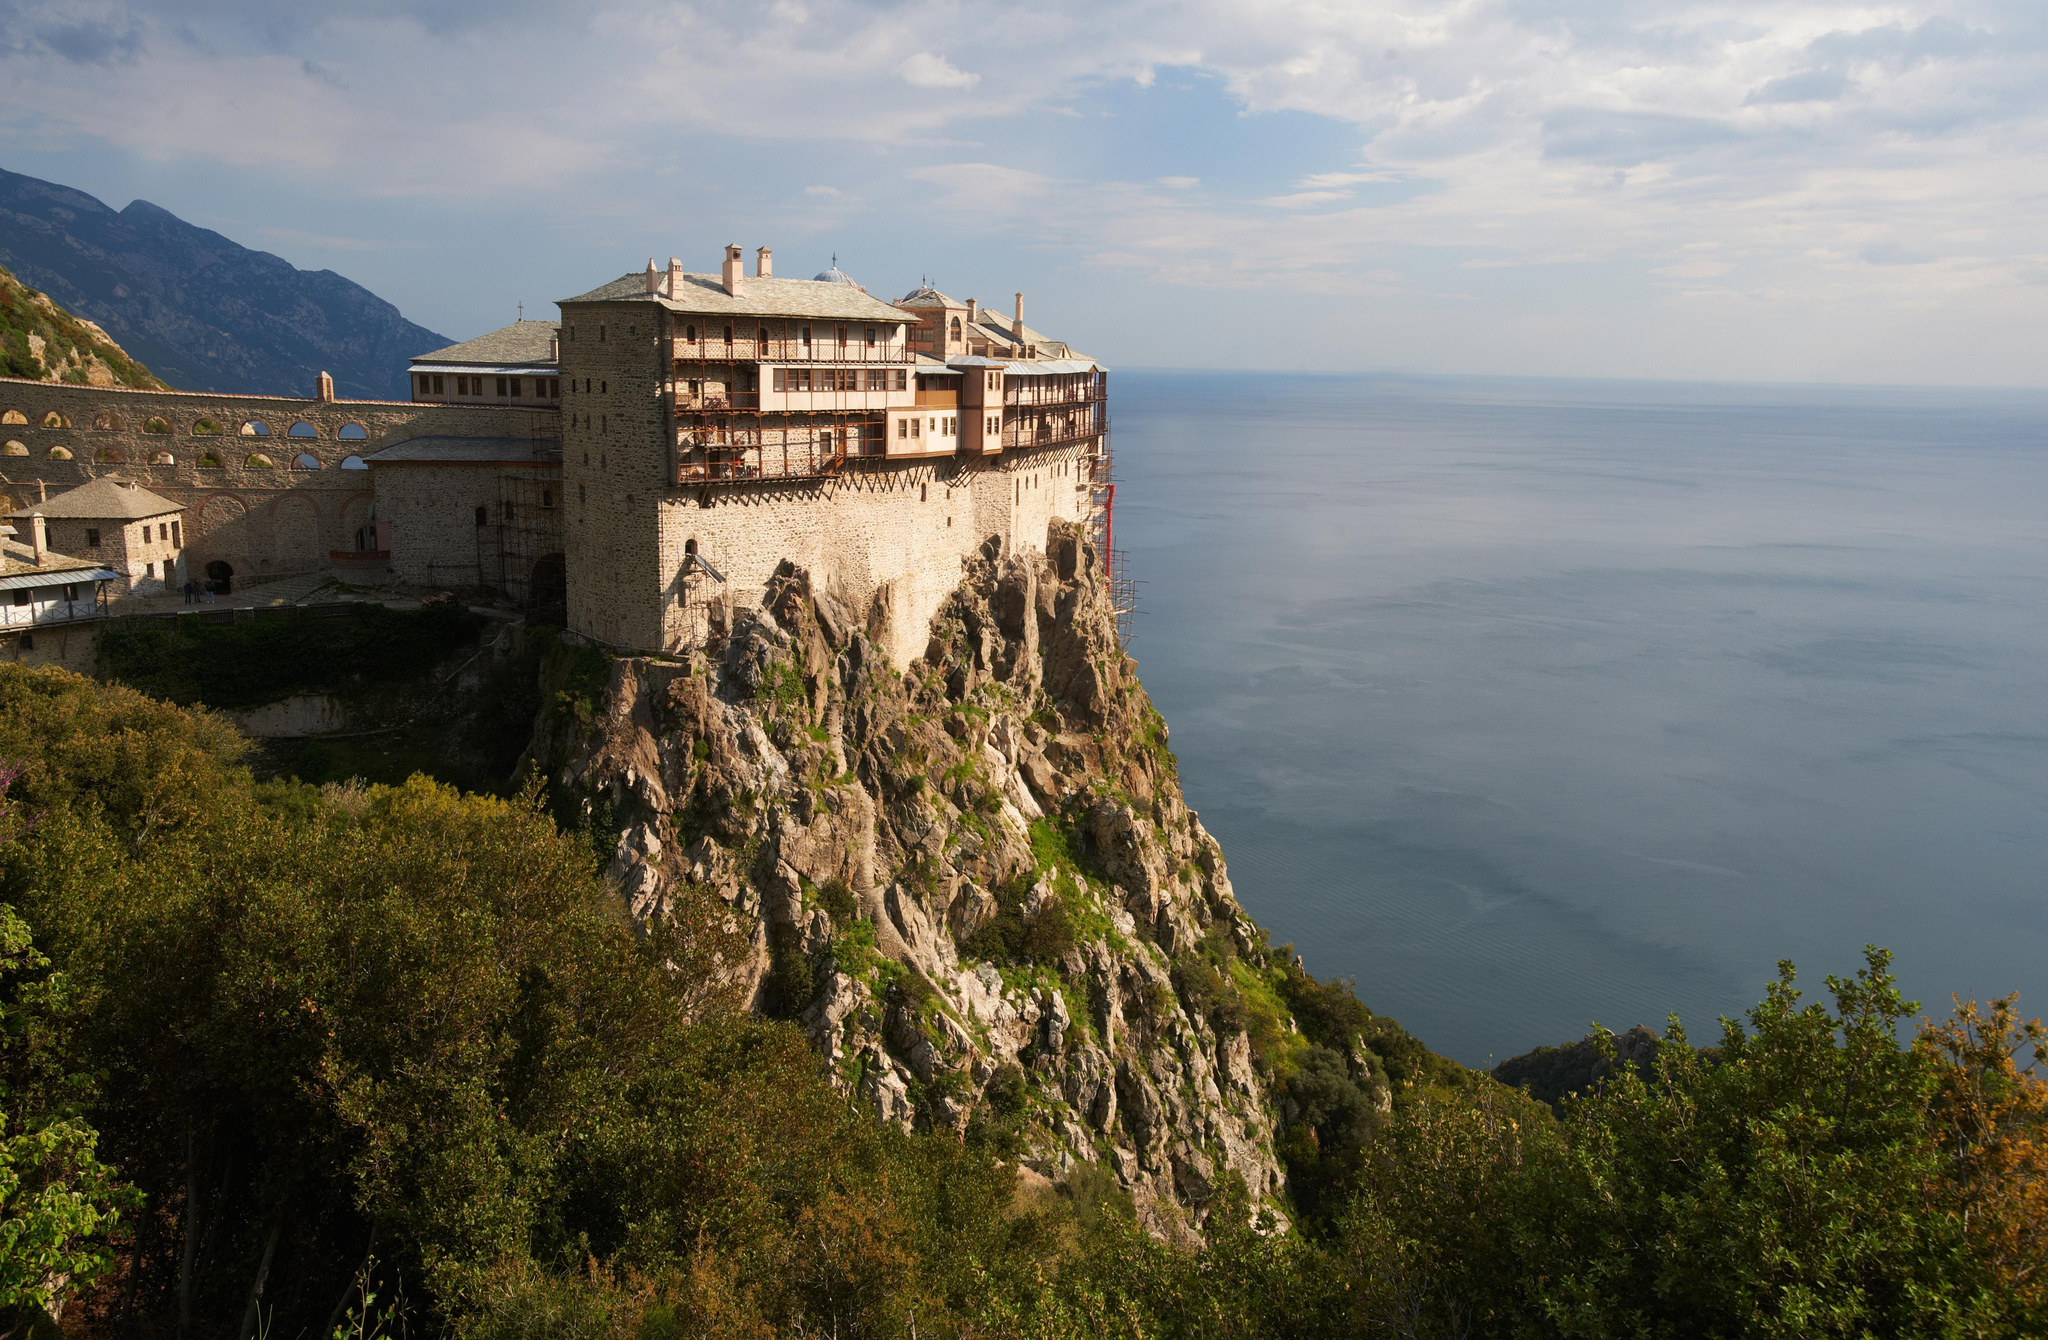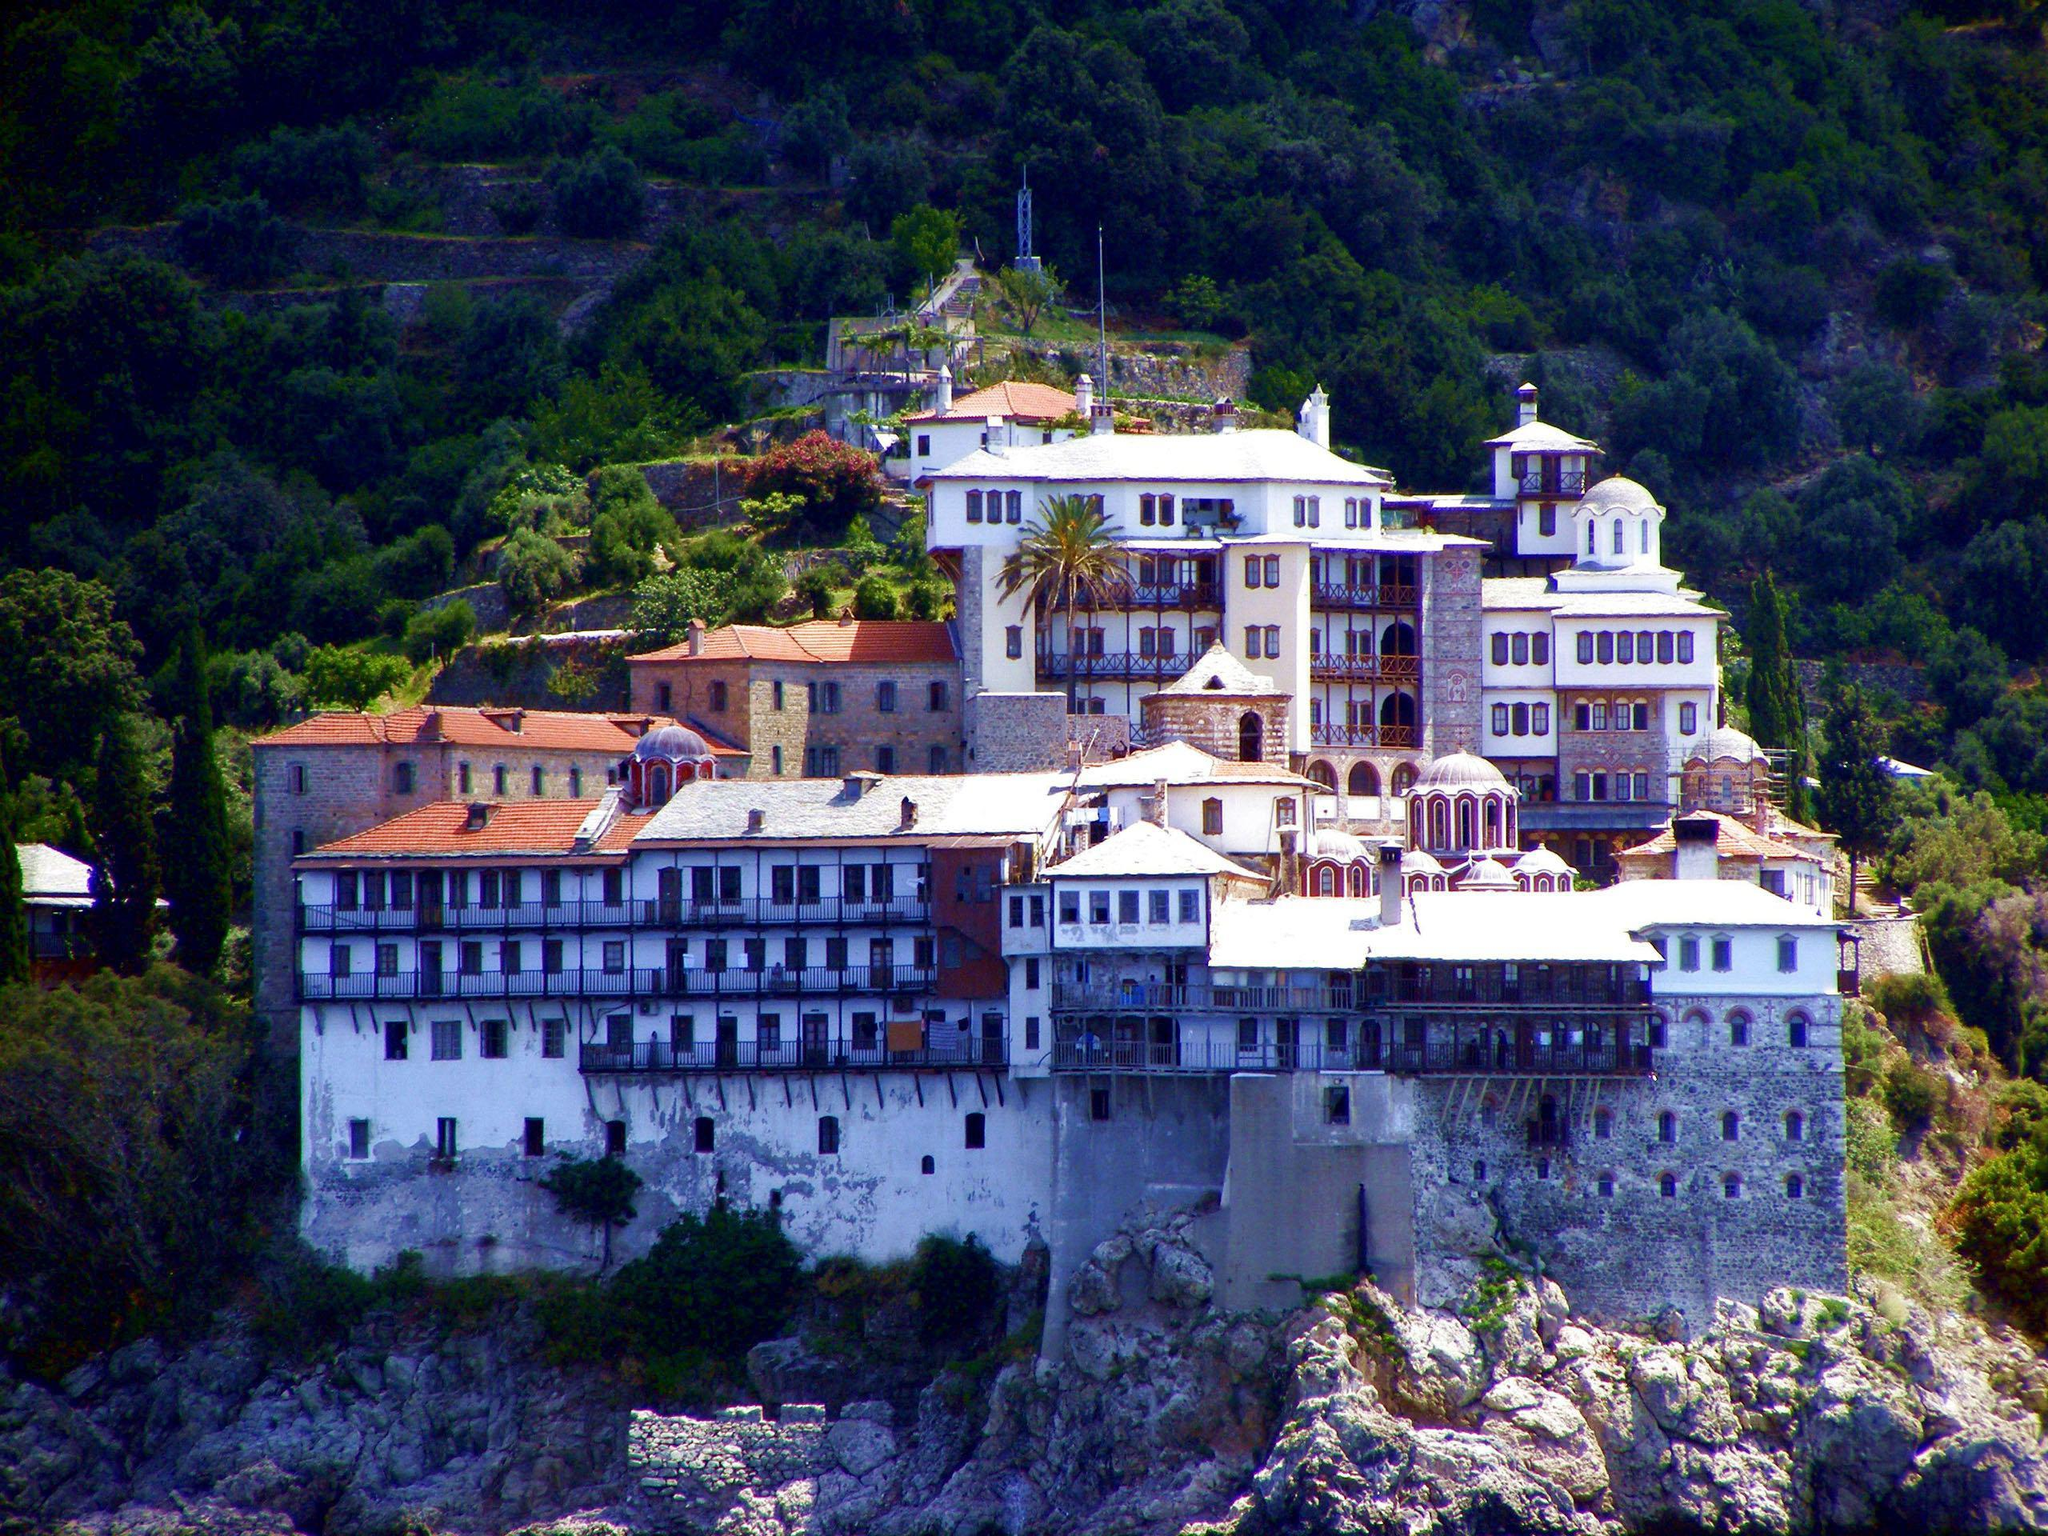The first image is the image on the left, the second image is the image on the right. Analyze the images presented: Is the assertion "The ocean is visible behind the buildings and cliffside in the left image, but it is not visible in the right image." valid? Answer yes or no. Yes. The first image is the image on the left, the second image is the image on the right. Analyze the images presented: Is the assertion "In at least one image there is a large home on top of a rock mountain with one mountain behind it to the left." valid? Answer yes or no. Yes. 